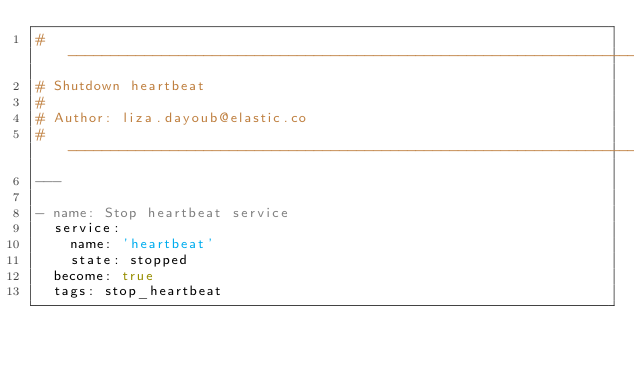<code> <loc_0><loc_0><loc_500><loc_500><_YAML_># ----------------------------------------------------------------------------
# Shutdown heartbeat
#
# Author: liza.dayoub@elastic.co
# ----------------------------------------------------------------------------
---

- name: Stop heartbeat service
  service:
    name: 'heartbeat'
    state: stopped
  become: true
  tags: stop_heartbeat
</code> 